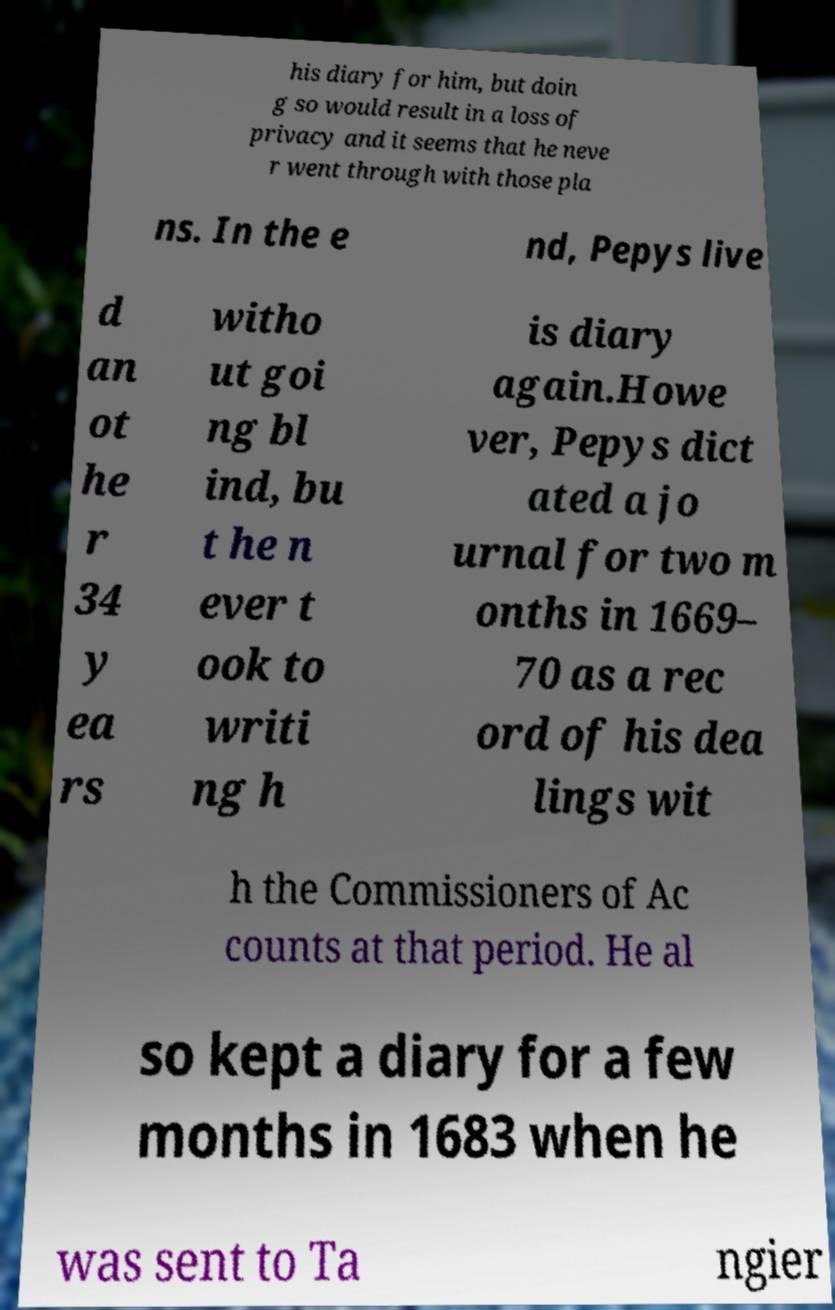Could you assist in decoding the text presented in this image and type it out clearly? his diary for him, but doin g so would result in a loss of privacy and it seems that he neve r went through with those pla ns. In the e nd, Pepys live d an ot he r 34 y ea rs witho ut goi ng bl ind, bu t he n ever t ook to writi ng h is diary again.Howe ver, Pepys dict ated a jo urnal for two m onths in 1669– 70 as a rec ord of his dea lings wit h the Commissioners of Ac counts at that period. He al so kept a diary for a few months in 1683 when he was sent to Ta ngier 